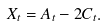Convert formula to latex. <formula><loc_0><loc_0><loc_500><loc_500>X _ { t } = A _ { t } - 2 C _ { t } .</formula> 